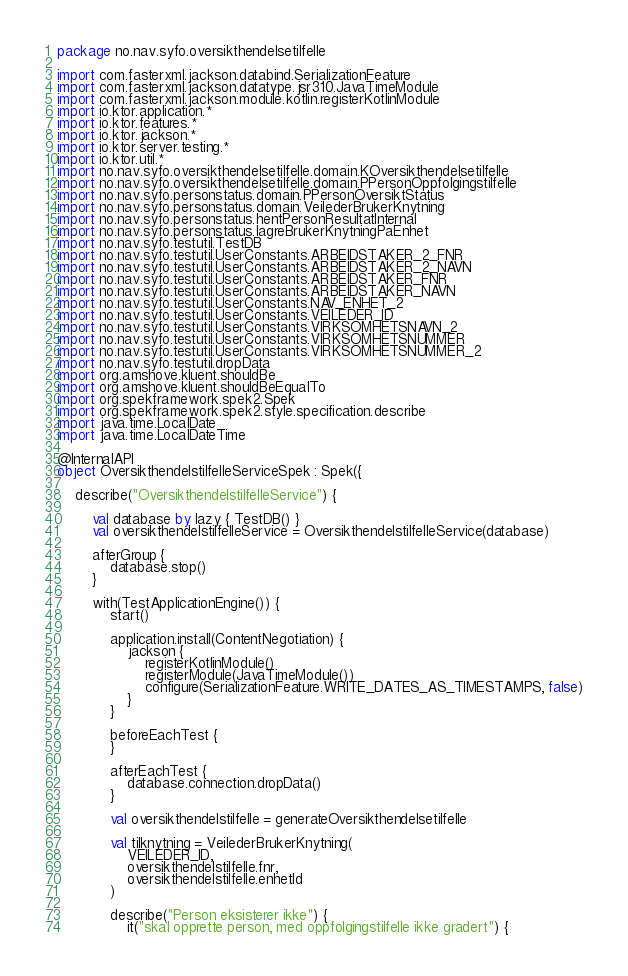Convert code to text. <code><loc_0><loc_0><loc_500><loc_500><_Kotlin_>package no.nav.syfo.oversikthendelsetilfelle

import com.fasterxml.jackson.databind.SerializationFeature
import com.fasterxml.jackson.datatype.jsr310.JavaTimeModule
import com.fasterxml.jackson.module.kotlin.registerKotlinModule
import io.ktor.application.*
import io.ktor.features.*
import io.ktor.jackson.*
import io.ktor.server.testing.*
import io.ktor.util.*
import no.nav.syfo.oversikthendelsetilfelle.domain.KOversikthendelsetilfelle
import no.nav.syfo.oversikthendelsetilfelle.domain.PPersonOppfolgingstilfelle
import no.nav.syfo.personstatus.domain.PPersonOversiktStatus
import no.nav.syfo.personstatus.domain.VeilederBrukerKnytning
import no.nav.syfo.personstatus.hentPersonResultatInternal
import no.nav.syfo.personstatus.lagreBrukerKnytningPaEnhet
import no.nav.syfo.testutil.TestDB
import no.nav.syfo.testutil.UserConstants.ARBEIDSTAKER_2_FNR
import no.nav.syfo.testutil.UserConstants.ARBEIDSTAKER_2_NAVN
import no.nav.syfo.testutil.UserConstants.ARBEIDSTAKER_FNR
import no.nav.syfo.testutil.UserConstants.ARBEIDSTAKER_NAVN
import no.nav.syfo.testutil.UserConstants.NAV_ENHET_2
import no.nav.syfo.testutil.UserConstants.VEILEDER_ID
import no.nav.syfo.testutil.UserConstants.VIRKSOMHETSNAVN_2
import no.nav.syfo.testutil.UserConstants.VIRKSOMHETSNUMMER
import no.nav.syfo.testutil.UserConstants.VIRKSOMHETSNUMMER_2
import no.nav.syfo.testutil.dropData
import org.amshove.kluent.shouldBe
import org.amshove.kluent.shouldBeEqualTo
import org.spekframework.spek2.Spek
import org.spekframework.spek2.style.specification.describe
import java.time.LocalDate
import java.time.LocalDateTime

@InternalAPI
object OversikthendelstilfelleServiceSpek : Spek({

    describe("OversikthendelstilfelleService") {

        val database by lazy { TestDB() }
        val oversikthendelstilfelleService = OversikthendelstilfelleService(database)

        afterGroup {
            database.stop()
        }

        with(TestApplicationEngine()) {
            start()

            application.install(ContentNegotiation) {
                jackson {
                    registerKotlinModule()
                    registerModule(JavaTimeModule())
                    configure(SerializationFeature.WRITE_DATES_AS_TIMESTAMPS, false)
                }
            }

            beforeEachTest {
            }

            afterEachTest {
                database.connection.dropData()
            }

            val oversikthendelstilfelle = generateOversikthendelsetilfelle

            val tilknytning = VeilederBrukerKnytning(
                VEILEDER_ID,
                oversikthendelstilfelle.fnr,
                oversikthendelstilfelle.enhetId
            )

            describe("Person eksisterer ikke") {
                it("skal opprette person, med oppfolgingstilfelle ikke gradert") {</code> 